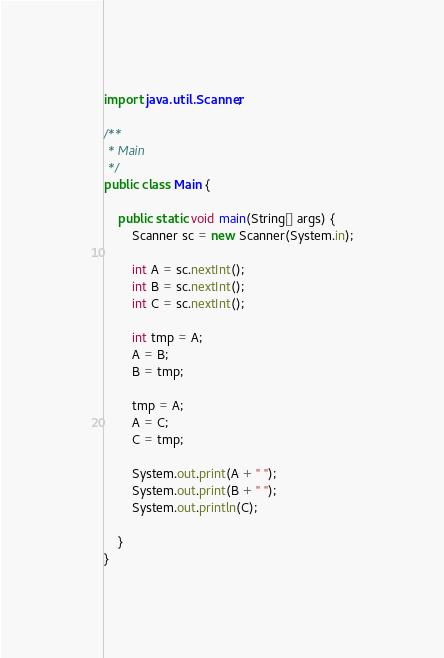<code> <loc_0><loc_0><loc_500><loc_500><_Java_>import java.util.Scanner;

/**
 * Main
 */
public class Main {

    public static void main(String[] args) {
        Scanner sc = new Scanner(System.in);

        int A = sc.nextInt();
        int B = sc.nextInt();
        int C = sc.nextInt();

        int tmp = A;
        A = B;
        B = tmp;

        tmp = A;
        A = C;
        C = tmp;

        System.out.print(A + " ");
        System.out.print(B + " ");
        System.out.println(C);
        
    }
}</code> 